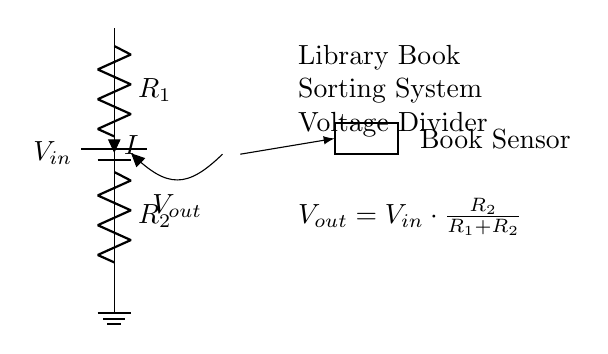What is the input voltage? The input voltage is labeled as V in the circuit diagram, which represents the voltage supplied to the system.
Answer: V in What do the resistors represent? The resistors R1 and R2 in the diagram represent specific resistances that help determine the output voltage of the voltage divider.
Answer: R1 and R2 What is the equation for the output voltage? The output voltage equation is given directly in the circuit diagram: V out equals V in times R2 divided by R1 plus R2. This can be derived from the voltage divider rule.
Answer: V out = V in * R2 / (R1 + R2) What is the function of the book sensor? The book sensor detects the presence of books as part of the automated sorting process in the library system.
Answer: Book detection If R1 is twice the value of R2, what would be the output voltage to input voltage ratio? If R1 is twice R2, then the output voltage would be one-third of the input voltage. This is calculated using the voltage divider formula with R1 as two times R2.
Answer: One-third What happens to the output voltage if R1 is increased? Increasing R1 while keeping R2 constant will decrease the output voltage as per the voltage divider formula, since the ratio of R2 to the total resistance will decline.
Answer: Decreases What is the purpose of the voltage divider in this circuit? The voltage divider's purpose is to provide the appropriate output voltage required by the book sensor, ensuring proper operation within its voltage range.
Answer: Adjust sensor voltage 